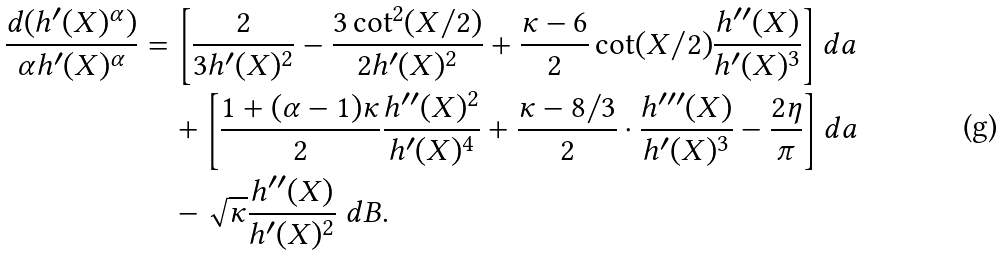Convert formula to latex. <formula><loc_0><loc_0><loc_500><loc_500>\frac { d ( h ^ { \prime } ( X ) ^ { \alpha } ) } { \alpha h ^ { \prime } ( X ) ^ { \alpha } } & = \left [ \frac { 2 } { 3 h ^ { \prime } ( X ) ^ { 2 } } - \frac { 3 \cot ^ { 2 } ( X / 2 ) } { 2 h ^ { \prime } ( X ) ^ { 2 } } + \frac { \kappa - 6 } { 2 } \cot ( X / 2 ) \frac { h ^ { \prime \prime } ( X ) } { h ^ { \prime } ( X ) ^ { 3 } } \right ] d a \\ & \quad + \left [ \frac { 1 + ( \alpha - 1 ) \kappa } { 2 } \frac { h ^ { \prime \prime } ( X ) ^ { 2 } } { h ^ { \prime } ( X ) ^ { 4 } } + \frac { \kappa - 8 / 3 } { 2 } \cdot \frac { h ^ { \prime \prime \prime } ( X ) } { h ^ { \prime } ( X ) ^ { 3 } } - \frac { 2 \eta } { \pi } \right ] d a \\ & \quad - \sqrt { \kappa } \frac { h ^ { \prime \prime } ( X ) } { h ^ { \prime } ( X ) ^ { 2 } } \ d B .</formula> 